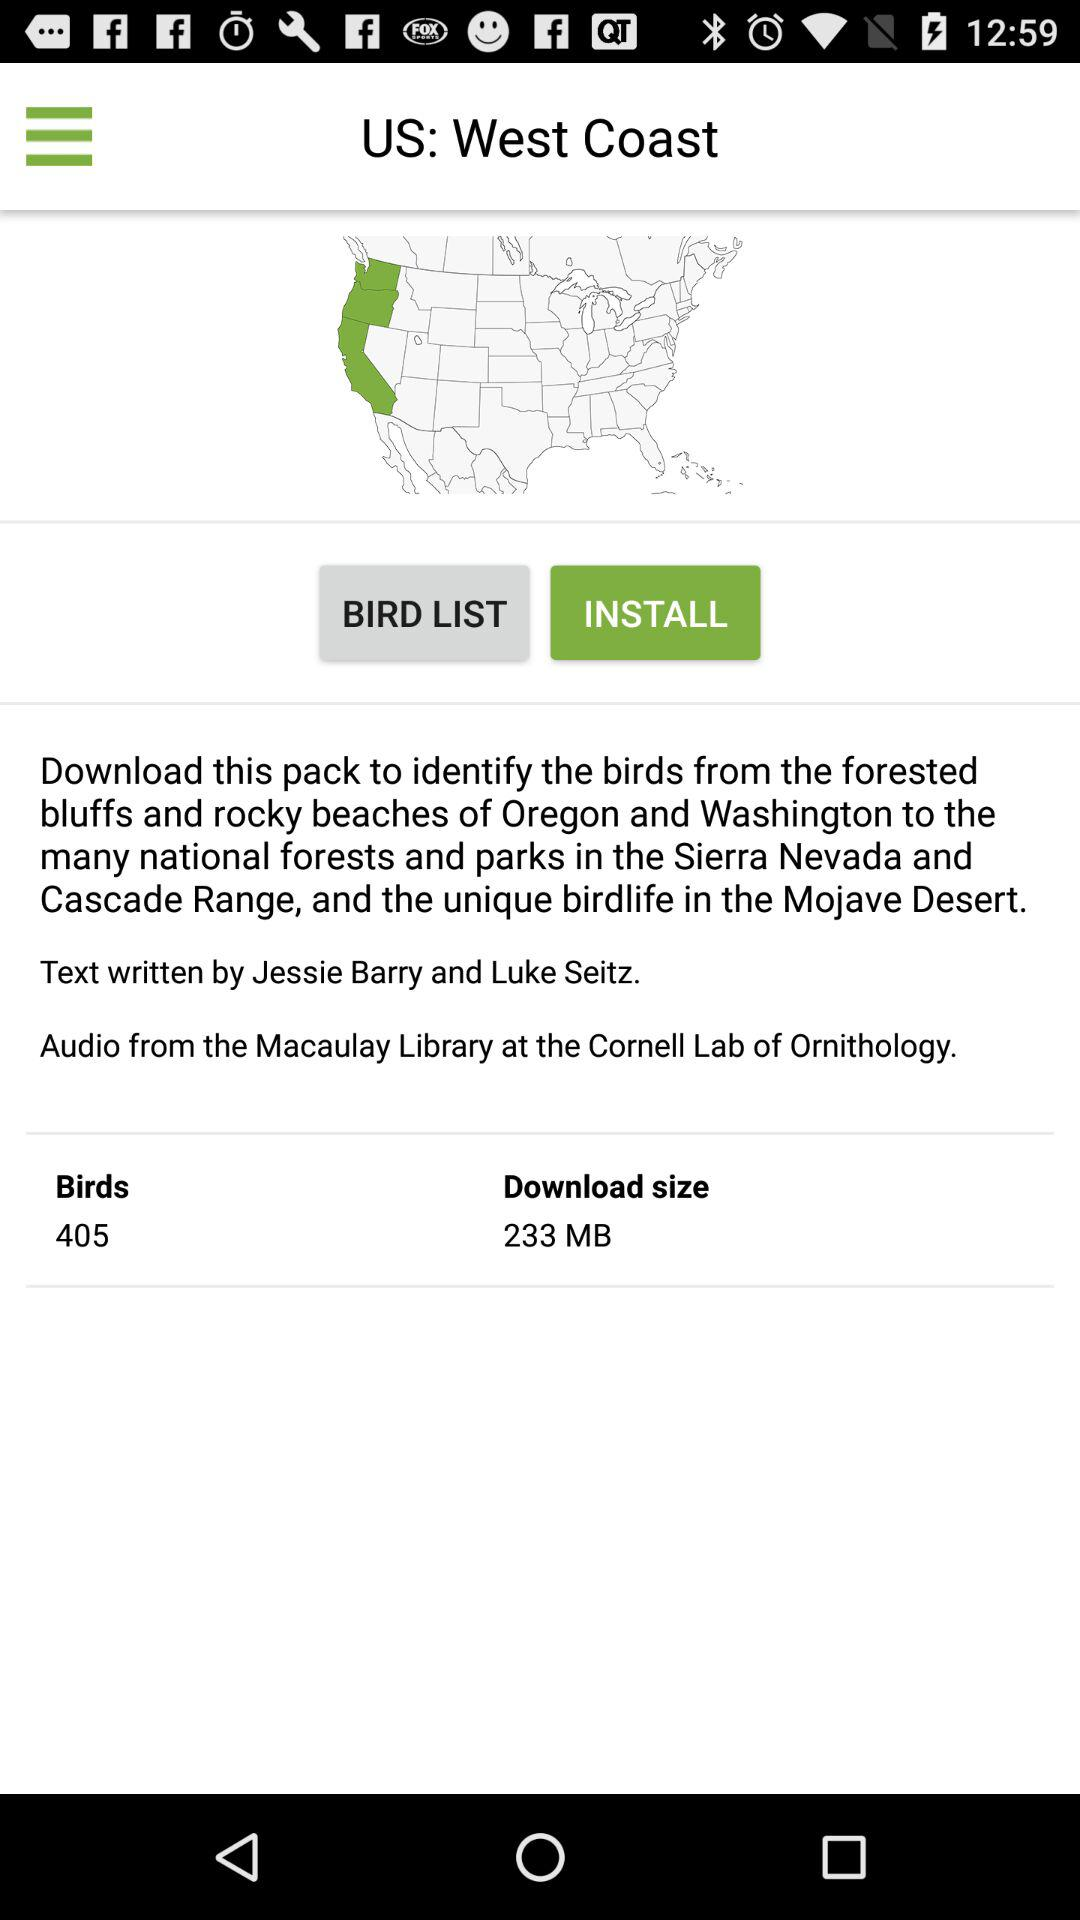What is the download size? The download size is 233 MB. 